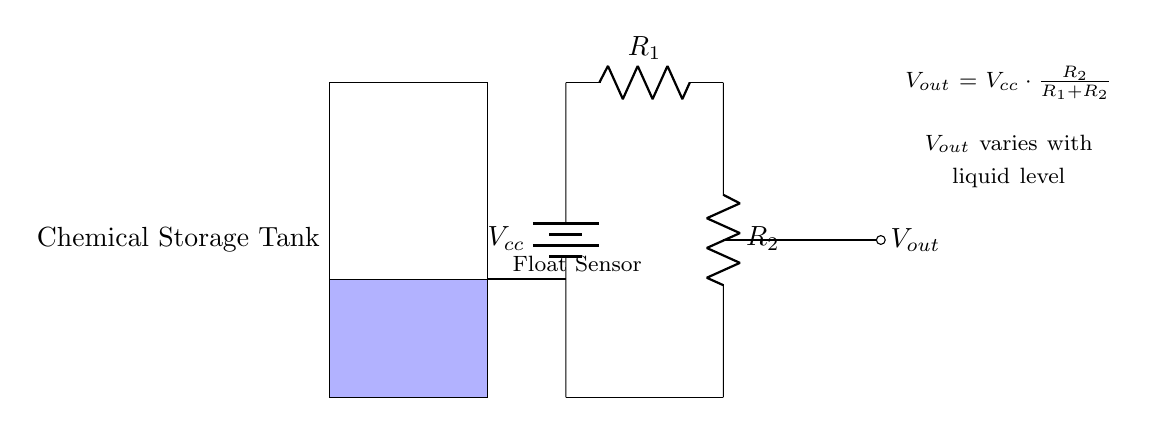What is the supply voltage in the circuit? The supply voltage is indicated by the battery labeled $V_{cc}$, which provides the circuit with electrical power.
Answer: Vcc What is the function of the float sensor? The float sensor is used to monitor the liquid level within the chemical storage tank by detecting how high the liquid is, which affects the output voltage of the voltage divider.
Answer: Monitoring liquid level What does the output voltage depend on? The output voltage, labeled $V_{out}$, depends on the values of resistors $R_1$ and $R_2$ according to the voltage divider formula, which shows that the output changes with the ratio of these resistances.
Answer: Resistor values What is the formula for the output voltage? The formula for the output voltage $V_{out}$ is provided directly in the circuit diagram: $V_{out} = V_{cc} \cdot \frac{R_2}{R_1 + R_2}$. This correlates the output voltage to the resistors and the supply voltage.
Answer: Vout = Vcc * (R2 / (R1 + R2)) What type of circuit is shown in the diagram? The circuit shown is a voltage divider, which is specifically designed to divide the voltage between two resistors in a series connection, giving a lower output voltage based on the input voltage and resistance values.
Answer: Voltage divider 